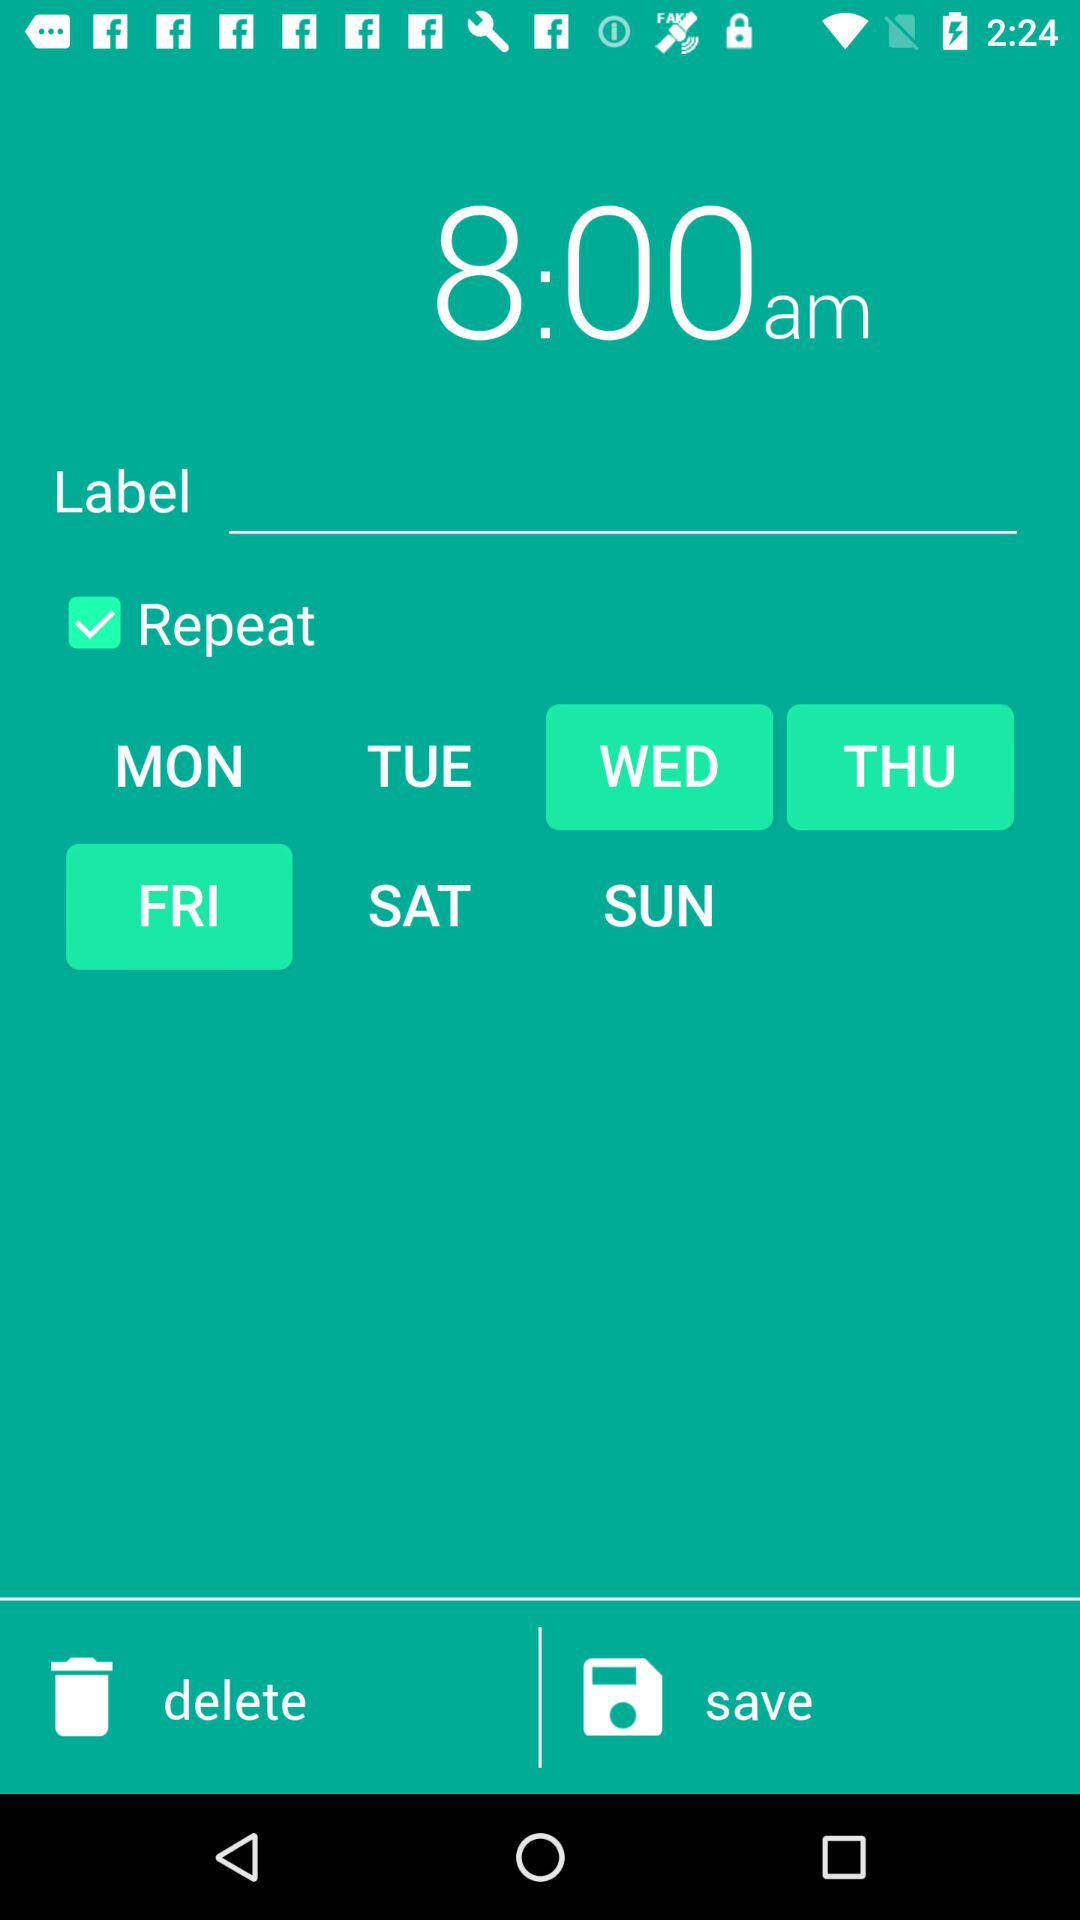Which days are selected for the repeat alarm? The selected days for the repeat alarm are Wednesday, Thursday and Friday. 